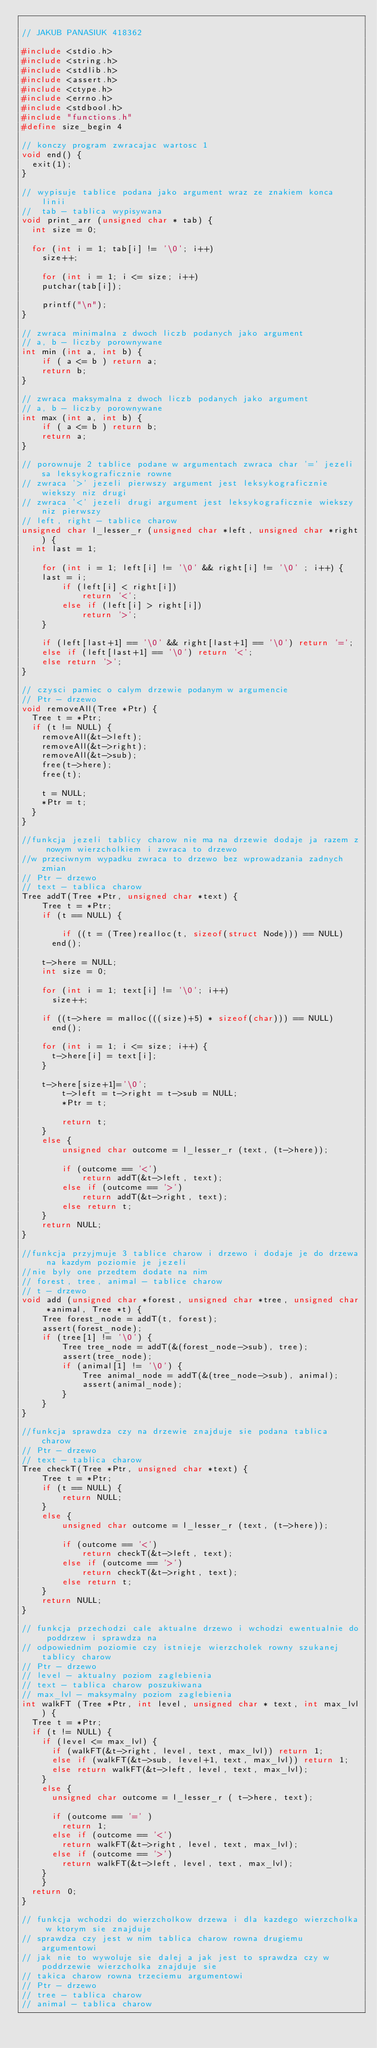<code> <loc_0><loc_0><loc_500><loc_500><_C_>
// JAKUB PANASIUK 418362

#include <stdio.h>
#include <string.h>
#include <stdlib.h>
#include <assert.h>
#include <ctype.h>
#include <errno.h>
#include <stdbool.h>
#include "functions.h"
#define size_begin 4

// konczy program zwracajac wartosc 1 
void end() {
	exit(1);
}

// wypisuje tablice podana jako argument wraz ze znakiem konca linii
//  tab - tablica wypisywana
void print_arr (unsigned char * tab) {
	int size = 0;

	for (int i = 1; tab[i] != '\0'; i++)
		size++;

    for (int i = 1; i <= size; i++)
		putchar(tab[i]);

    printf("\n");
}

// zwraca minimalna z dwoch liczb podanych jako argument
// a, b - liczby porownywane
int min (int a, int b) {
    if ( a <= b ) return a;
    return b;
}

// zwraca maksymalna z dwoch liczb podanych jako argument
// a, b - liczby porownywane
int max (int a, int b) {
    if ( a <= b ) return b;
    return a;
}

// porownuje 2 tablice podane w argumentach zwraca char '=' jezeli sa leksykograficznie rowne
// zwraca '>' jezeli pierwszy argument jest leksykograficznie wiekszy niz drugi
// zwraca '<' jezeli drugi argument jest leksykograficznie wiekszy niz pierwszy
// left, right - tablice charow
unsigned char l_lesser_r (unsigned char *left, unsigned char *right) {
	int last = 1;

    for (int i = 1; left[i] != '\0' && right[i] != '\0' ; i++) {
		last = i;
        if (left[i] < right[i])
            return '<';
        else if (left[i] > right[i])
            return '>';
    }

    if (left[last+1] == '\0' && right[last+1] == '\0') return '=';
    else if (left[last+1] == '\0') return '<';
    else return '>';
}

// czysci pamiec o calym drzewie podanym w argumencie
// Ptr - drzewo
void removeAll(Tree *Ptr) {
	Tree t = *Ptr;
	if (t != NULL) {
		removeAll(&t->left);
		removeAll(&t->right);
		removeAll(&t->sub);
		free(t->here);
		free(t);

		t = NULL;
		*Ptr = t;
	}
}

//funkcja jezeli tablicy charow nie ma na drzewie dodaje ja razem z nowym wierzcholkiem i zwraca to drzewo
//w przeciwnym wypadku zwraca to drzewo bez wprowadzania zadnych zmian
// Ptr - drzewo
// text - tablica charow
Tree addT(Tree *Ptr, unsigned char *text) {
    Tree t = *Ptr;
    if (t == NULL) {

        if ((t = (Tree)realloc(t, sizeof(struct Node))) == NULL)
			end();

		t->here = NULL;
		int size = 0;

		for (int i = 1; text[i] != '\0'; i++)
			size++;

		if ((t->here = malloc(((size)+5) * sizeof(char))) == NULL) 
			end();

		for (int i = 1; i <= size; i++) {
			t->here[i] = text[i];
		}

		t->here[size+1]='\0';
        t->left = t->right = t->sub = NULL;
        *Ptr = t;

        return t;
    }
    else {
        unsigned char outcome = l_lesser_r (text, (t->here));

        if (outcome == '<')
            return addT(&t->left, text);
        else if (outcome == '>')
            return addT(&t->right, text);
        else return t;
    }
    return NULL;
}

//funkcja przyjmuje 3 tablice charow i drzewo i dodaje je do drzewa na kazdym poziomie je jezeli
//nie byly one przedtem dodate na nim
// forest, tree, animal - tablice charow
// t - drzewo
void add (unsigned char *forest, unsigned char *tree, unsigned char *animal, Tree *t) {
    Tree forest_node = addT(t, forest);
    assert(forest_node);
    if (tree[1] != '\0') {
        Tree tree_node = addT(&(forest_node->sub), tree);
        assert(tree_node);
        if (animal[1] != '\0') {
            Tree animal_node = addT(&(tree_node->sub), animal);
            assert(animal_node);
        }
    }
}

//funkcja sprawdza czy na drzewie znajduje sie podana tablica charow
// Ptr - drzewo
// text - tablica charow
Tree checkT(Tree *Ptr, unsigned char *text) {
    Tree t = *Ptr;
    if (t == NULL) {
        return NULL;
    }
    else {
        unsigned char outcome = l_lesser_r (text, (t->here));

        if (outcome == '<')
            return checkT(&t->left, text);
        else if (outcome == '>')
            return checkT(&t->right, text);
        else return t;
    }
    return NULL;
}

// funkcja przechodzi cale aktualne drzewo i wchodzi ewentualnie do poddrzew i sprawdza na
// odpowiednim poziomie czy istnieje wierzcholek rowny szukanej tablicy charow
// Ptr - drzewo
// level - aktualny poziom zaglebienia
// text - tablica charow poszukiwana
// max_lvl - maksymalny poziom zaglebienia
int walkFT (Tree *Ptr, int level, unsigned char * text, int max_lvl) {
	Tree t = *Ptr;
	if (t != NULL) {
		if (level <= max_lvl) {
			if (walkFT(&t->right, level, text, max_lvl)) return 1;
			else if (walkFT(&t->sub, level+1, text, max_lvl)) return 1;
			else return walkFT(&t->left, level, text, max_lvl);
		}
		else {
			unsigned char outcome = l_lesser_r ( t->here, text);

			if (outcome == '=' )
				return 1;
			else if (outcome == '<') 
				return walkFT(&t->right, level, text, max_lvl);
			else if (outcome == '>')
				return walkFT(&t->left, level, text, max_lvl);
		}
  	}
	return 0;
}

// funkcja wchodzi do wierzcholkow drzewa i dla kazdego wierzcholka w ktorym sie znajduje
// sprawdza czy jest w nim tablica charow rowna drugiemu argumentowi
// jak nie to wywoluje sie dalej a jak jest to sprawdza czy w poddrzewie wierzcholka znajduje sie
// takica charow rowna trzeciemu argumentowi
// Ptr - drzewo
// tree - tablica charow 
// animal - tablica charow</code> 